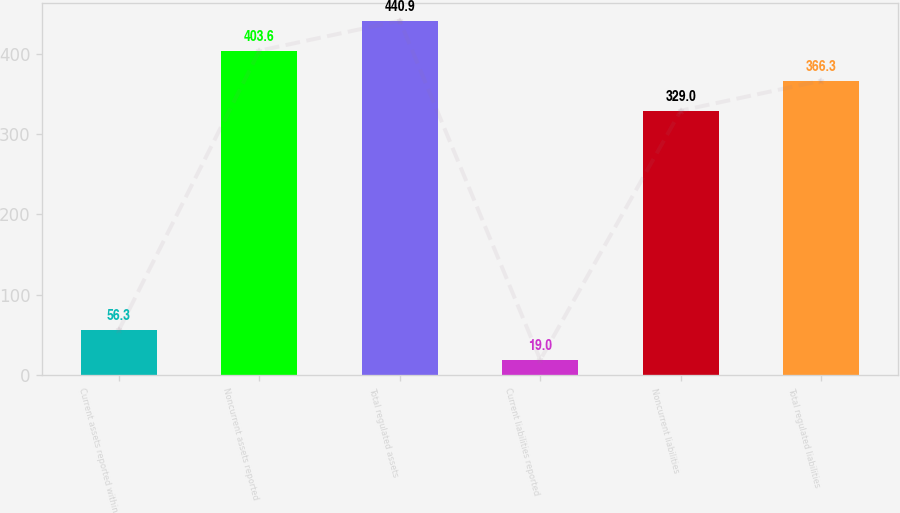<chart> <loc_0><loc_0><loc_500><loc_500><bar_chart><fcel>Current assets reported within<fcel>Noncurrent assets reported<fcel>Total regulated assets<fcel>Current liabilities reported<fcel>Noncurrent liabilities<fcel>Total regulated liabilities<nl><fcel>56.3<fcel>403.6<fcel>440.9<fcel>19<fcel>329<fcel>366.3<nl></chart> 